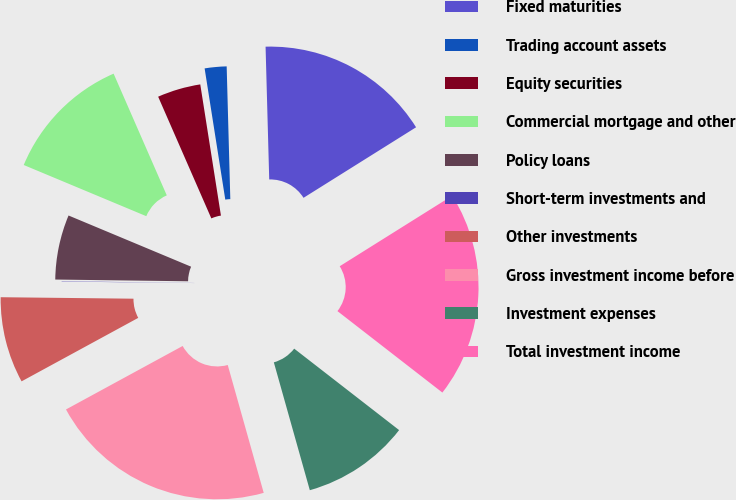<chart> <loc_0><loc_0><loc_500><loc_500><pie_chart><fcel>Fixed maturities<fcel>Trading account assets<fcel>Equity securities<fcel>Commercial mortgage and other<fcel>Policy loans<fcel>Short-term investments and<fcel>Other investments<fcel>Gross investment income before<fcel>Investment expenses<fcel>Total investment income<nl><fcel>16.53%<fcel>2.05%<fcel>4.07%<fcel>12.15%<fcel>6.09%<fcel>0.03%<fcel>8.11%<fcel>21.44%<fcel>10.13%<fcel>19.42%<nl></chart> 